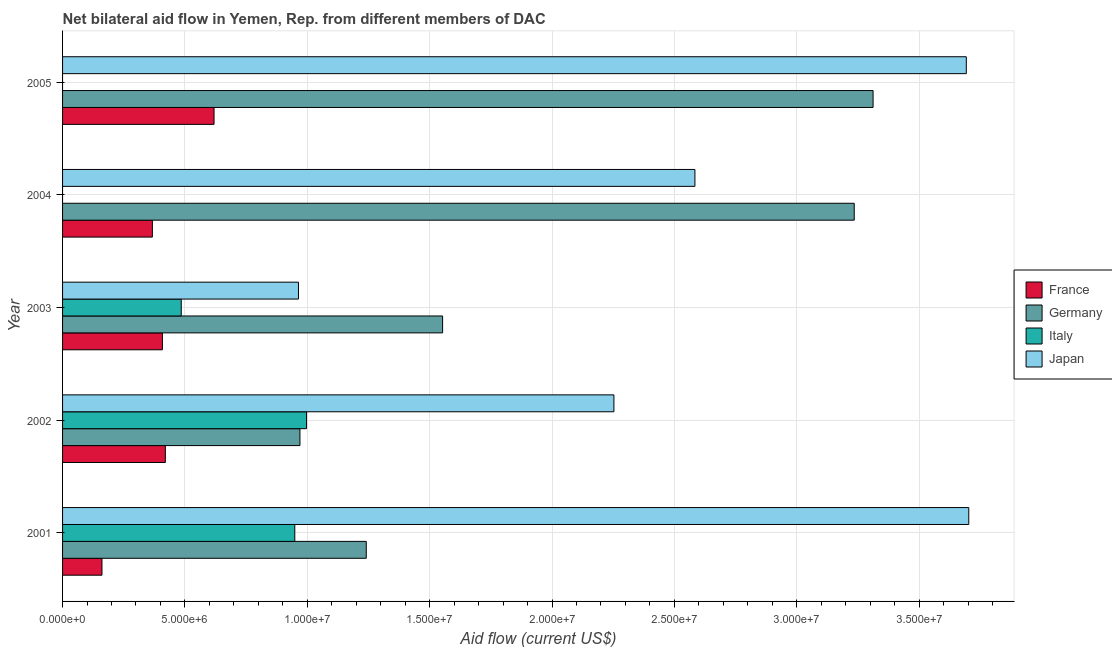How many different coloured bars are there?
Offer a very short reply. 4. How many bars are there on the 1st tick from the top?
Your answer should be compact. 3. How many bars are there on the 4th tick from the bottom?
Make the answer very short. 3. What is the label of the 5th group of bars from the top?
Offer a very short reply. 2001. In how many cases, is the number of bars for a given year not equal to the number of legend labels?
Make the answer very short. 2. What is the amount of aid given by france in 2001?
Provide a short and direct response. 1.61e+06. Across all years, what is the maximum amount of aid given by germany?
Your response must be concise. 3.31e+07. Across all years, what is the minimum amount of aid given by japan?
Offer a very short reply. 9.64e+06. In which year was the amount of aid given by italy maximum?
Your answer should be very brief. 2002. What is the total amount of aid given by germany in the graph?
Your response must be concise. 1.03e+08. What is the difference between the amount of aid given by france in 2003 and that in 2004?
Your answer should be very brief. 4.10e+05. What is the difference between the amount of aid given by japan in 2003 and the amount of aid given by italy in 2001?
Your answer should be very brief. 1.50e+05. What is the average amount of aid given by germany per year?
Your answer should be very brief. 2.06e+07. In the year 2003, what is the difference between the amount of aid given by japan and amount of aid given by france?
Offer a terse response. 5.56e+06. What is the ratio of the amount of aid given by japan in 2001 to that in 2005?
Give a very brief answer. 1. Is the amount of aid given by france in 2001 less than that in 2005?
Your answer should be compact. Yes. What is the difference between the highest and the second highest amount of aid given by italy?
Your answer should be compact. 4.80e+05. What is the difference between the highest and the lowest amount of aid given by france?
Make the answer very short. 4.58e+06. Is the sum of the amount of aid given by germany in 2003 and 2004 greater than the maximum amount of aid given by japan across all years?
Provide a succinct answer. Yes. Is it the case that in every year, the sum of the amount of aid given by italy and amount of aid given by germany is greater than the sum of amount of aid given by japan and amount of aid given by france?
Provide a succinct answer. No. Is it the case that in every year, the sum of the amount of aid given by france and amount of aid given by germany is greater than the amount of aid given by italy?
Keep it short and to the point. Yes. Are all the bars in the graph horizontal?
Offer a terse response. Yes. Where does the legend appear in the graph?
Ensure brevity in your answer.  Center right. What is the title of the graph?
Your answer should be very brief. Net bilateral aid flow in Yemen, Rep. from different members of DAC. What is the Aid flow (current US$) of France in 2001?
Keep it short and to the point. 1.61e+06. What is the Aid flow (current US$) of Germany in 2001?
Keep it short and to the point. 1.24e+07. What is the Aid flow (current US$) in Italy in 2001?
Provide a succinct answer. 9.49e+06. What is the Aid flow (current US$) of Japan in 2001?
Give a very brief answer. 3.70e+07. What is the Aid flow (current US$) in France in 2002?
Your response must be concise. 4.20e+06. What is the Aid flow (current US$) of Germany in 2002?
Give a very brief answer. 9.70e+06. What is the Aid flow (current US$) of Italy in 2002?
Keep it short and to the point. 9.97e+06. What is the Aid flow (current US$) in Japan in 2002?
Offer a terse response. 2.25e+07. What is the Aid flow (current US$) in France in 2003?
Your answer should be compact. 4.08e+06. What is the Aid flow (current US$) in Germany in 2003?
Give a very brief answer. 1.55e+07. What is the Aid flow (current US$) of Italy in 2003?
Your response must be concise. 4.85e+06. What is the Aid flow (current US$) in Japan in 2003?
Your answer should be compact. 9.64e+06. What is the Aid flow (current US$) in France in 2004?
Your answer should be very brief. 3.67e+06. What is the Aid flow (current US$) in Germany in 2004?
Your answer should be compact. 3.24e+07. What is the Aid flow (current US$) of Italy in 2004?
Provide a succinct answer. 0. What is the Aid flow (current US$) in Japan in 2004?
Your response must be concise. 2.58e+07. What is the Aid flow (current US$) of France in 2005?
Ensure brevity in your answer.  6.19e+06. What is the Aid flow (current US$) of Germany in 2005?
Your answer should be very brief. 3.31e+07. What is the Aid flow (current US$) in Italy in 2005?
Offer a very short reply. 0. What is the Aid flow (current US$) in Japan in 2005?
Your answer should be very brief. 3.69e+07. Across all years, what is the maximum Aid flow (current US$) of France?
Offer a very short reply. 6.19e+06. Across all years, what is the maximum Aid flow (current US$) in Germany?
Offer a terse response. 3.31e+07. Across all years, what is the maximum Aid flow (current US$) in Italy?
Provide a short and direct response. 9.97e+06. Across all years, what is the maximum Aid flow (current US$) of Japan?
Offer a terse response. 3.70e+07. Across all years, what is the minimum Aid flow (current US$) in France?
Give a very brief answer. 1.61e+06. Across all years, what is the minimum Aid flow (current US$) in Germany?
Your answer should be very brief. 9.70e+06. Across all years, what is the minimum Aid flow (current US$) of Italy?
Your answer should be compact. 0. Across all years, what is the minimum Aid flow (current US$) of Japan?
Provide a succinct answer. 9.64e+06. What is the total Aid flow (current US$) of France in the graph?
Your answer should be compact. 1.98e+07. What is the total Aid flow (current US$) of Germany in the graph?
Offer a terse response. 1.03e+08. What is the total Aid flow (current US$) in Italy in the graph?
Offer a terse response. 2.43e+07. What is the total Aid flow (current US$) of Japan in the graph?
Ensure brevity in your answer.  1.32e+08. What is the difference between the Aid flow (current US$) of France in 2001 and that in 2002?
Your answer should be very brief. -2.59e+06. What is the difference between the Aid flow (current US$) of Germany in 2001 and that in 2002?
Your response must be concise. 2.71e+06. What is the difference between the Aid flow (current US$) of Italy in 2001 and that in 2002?
Give a very brief answer. -4.80e+05. What is the difference between the Aid flow (current US$) in Japan in 2001 and that in 2002?
Your answer should be very brief. 1.45e+07. What is the difference between the Aid flow (current US$) in France in 2001 and that in 2003?
Your answer should be very brief. -2.47e+06. What is the difference between the Aid flow (current US$) in Germany in 2001 and that in 2003?
Make the answer very short. -3.12e+06. What is the difference between the Aid flow (current US$) of Italy in 2001 and that in 2003?
Give a very brief answer. 4.64e+06. What is the difference between the Aid flow (current US$) in Japan in 2001 and that in 2003?
Your answer should be compact. 2.74e+07. What is the difference between the Aid flow (current US$) in France in 2001 and that in 2004?
Provide a short and direct response. -2.06e+06. What is the difference between the Aid flow (current US$) of Germany in 2001 and that in 2004?
Ensure brevity in your answer.  -1.99e+07. What is the difference between the Aid flow (current US$) of Japan in 2001 and that in 2004?
Provide a short and direct response. 1.12e+07. What is the difference between the Aid flow (current US$) of France in 2001 and that in 2005?
Make the answer very short. -4.58e+06. What is the difference between the Aid flow (current US$) of Germany in 2001 and that in 2005?
Provide a succinct answer. -2.07e+07. What is the difference between the Aid flow (current US$) in Japan in 2001 and that in 2005?
Keep it short and to the point. 1.00e+05. What is the difference between the Aid flow (current US$) of Germany in 2002 and that in 2003?
Provide a short and direct response. -5.83e+06. What is the difference between the Aid flow (current US$) in Italy in 2002 and that in 2003?
Your answer should be compact. 5.12e+06. What is the difference between the Aid flow (current US$) of Japan in 2002 and that in 2003?
Your response must be concise. 1.29e+07. What is the difference between the Aid flow (current US$) of France in 2002 and that in 2004?
Keep it short and to the point. 5.30e+05. What is the difference between the Aid flow (current US$) in Germany in 2002 and that in 2004?
Your answer should be compact. -2.26e+07. What is the difference between the Aid flow (current US$) in Japan in 2002 and that in 2004?
Offer a terse response. -3.31e+06. What is the difference between the Aid flow (current US$) of France in 2002 and that in 2005?
Make the answer very short. -1.99e+06. What is the difference between the Aid flow (current US$) in Germany in 2002 and that in 2005?
Keep it short and to the point. -2.34e+07. What is the difference between the Aid flow (current US$) in Japan in 2002 and that in 2005?
Your answer should be very brief. -1.44e+07. What is the difference between the Aid flow (current US$) in France in 2003 and that in 2004?
Make the answer very short. 4.10e+05. What is the difference between the Aid flow (current US$) in Germany in 2003 and that in 2004?
Keep it short and to the point. -1.68e+07. What is the difference between the Aid flow (current US$) in Japan in 2003 and that in 2004?
Keep it short and to the point. -1.62e+07. What is the difference between the Aid flow (current US$) in France in 2003 and that in 2005?
Ensure brevity in your answer.  -2.11e+06. What is the difference between the Aid flow (current US$) of Germany in 2003 and that in 2005?
Your response must be concise. -1.76e+07. What is the difference between the Aid flow (current US$) in Japan in 2003 and that in 2005?
Keep it short and to the point. -2.73e+07. What is the difference between the Aid flow (current US$) of France in 2004 and that in 2005?
Provide a succinct answer. -2.52e+06. What is the difference between the Aid flow (current US$) of Germany in 2004 and that in 2005?
Your answer should be very brief. -7.70e+05. What is the difference between the Aid flow (current US$) in Japan in 2004 and that in 2005?
Your answer should be very brief. -1.11e+07. What is the difference between the Aid flow (current US$) of France in 2001 and the Aid flow (current US$) of Germany in 2002?
Keep it short and to the point. -8.09e+06. What is the difference between the Aid flow (current US$) of France in 2001 and the Aid flow (current US$) of Italy in 2002?
Offer a very short reply. -8.36e+06. What is the difference between the Aid flow (current US$) of France in 2001 and the Aid flow (current US$) of Japan in 2002?
Keep it short and to the point. -2.09e+07. What is the difference between the Aid flow (current US$) in Germany in 2001 and the Aid flow (current US$) in Italy in 2002?
Make the answer very short. 2.44e+06. What is the difference between the Aid flow (current US$) in Germany in 2001 and the Aid flow (current US$) in Japan in 2002?
Offer a terse response. -1.01e+07. What is the difference between the Aid flow (current US$) in Italy in 2001 and the Aid flow (current US$) in Japan in 2002?
Provide a succinct answer. -1.30e+07. What is the difference between the Aid flow (current US$) of France in 2001 and the Aid flow (current US$) of Germany in 2003?
Your answer should be compact. -1.39e+07. What is the difference between the Aid flow (current US$) of France in 2001 and the Aid flow (current US$) of Italy in 2003?
Make the answer very short. -3.24e+06. What is the difference between the Aid flow (current US$) of France in 2001 and the Aid flow (current US$) of Japan in 2003?
Offer a terse response. -8.03e+06. What is the difference between the Aid flow (current US$) of Germany in 2001 and the Aid flow (current US$) of Italy in 2003?
Your response must be concise. 7.56e+06. What is the difference between the Aid flow (current US$) in Germany in 2001 and the Aid flow (current US$) in Japan in 2003?
Your answer should be compact. 2.77e+06. What is the difference between the Aid flow (current US$) of France in 2001 and the Aid flow (current US$) of Germany in 2004?
Make the answer very short. -3.07e+07. What is the difference between the Aid flow (current US$) in France in 2001 and the Aid flow (current US$) in Japan in 2004?
Ensure brevity in your answer.  -2.42e+07. What is the difference between the Aid flow (current US$) in Germany in 2001 and the Aid flow (current US$) in Japan in 2004?
Your answer should be compact. -1.34e+07. What is the difference between the Aid flow (current US$) of Italy in 2001 and the Aid flow (current US$) of Japan in 2004?
Provide a short and direct response. -1.64e+07. What is the difference between the Aid flow (current US$) of France in 2001 and the Aid flow (current US$) of Germany in 2005?
Provide a succinct answer. -3.15e+07. What is the difference between the Aid flow (current US$) in France in 2001 and the Aid flow (current US$) in Japan in 2005?
Offer a terse response. -3.53e+07. What is the difference between the Aid flow (current US$) in Germany in 2001 and the Aid flow (current US$) in Japan in 2005?
Your answer should be very brief. -2.45e+07. What is the difference between the Aid flow (current US$) in Italy in 2001 and the Aid flow (current US$) in Japan in 2005?
Your answer should be very brief. -2.74e+07. What is the difference between the Aid flow (current US$) of France in 2002 and the Aid flow (current US$) of Germany in 2003?
Your response must be concise. -1.13e+07. What is the difference between the Aid flow (current US$) in France in 2002 and the Aid flow (current US$) in Italy in 2003?
Give a very brief answer. -6.50e+05. What is the difference between the Aid flow (current US$) in France in 2002 and the Aid flow (current US$) in Japan in 2003?
Offer a very short reply. -5.44e+06. What is the difference between the Aid flow (current US$) in Germany in 2002 and the Aid flow (current US$) in Italy in 2003?
Offer a terse response. 4.85e+06. What is the difference between the Aid flow (current US$) of Germany in 2002 and the Aid flow (current US$) of Japan in 2003?
Ensure brevity in your answer.  6.00e+04. What is the difference between the Aid flow (current US$) of Italy in 2002 and the Aid flow (current US$) of Japan in 2003?
Your answer should be very brief. 3.30e+05. What is the difference between the Aid flow (current US$) in France in 2002 and the Aid flow (current US$) in Germany in 2004?
Your answer should be very brief. -2.82e+07. What is the difference between the Aid flow (current US$) of France in 2002 and the Aid flow (current US$) of Japan in 2004?
Your answer should be very brief. -2.16e+07. What is the difference between the Aid flow (current US$) in Germany in 2002 and the Aid flow (current US$) in Japan in 2004?
Make the answer very short. -1.61e+07. What is the difference between the Aid flow (current US$) in Italy in 2002 and the Aid flow (current US$) in Japan in 2004?
Provide a succinct answer. -1.59e+07. What is the difference between the Aid flow (current US$) in France in 2002 and the Aid flow (current US$) in Germany in 2005?
Your answer should be compact. -2.89e+07. What is the difference between the Aid flow (current US$) of France in 2002 and the Aid flow (current US$) of Japan in 2005?
Provide a short and direct response. -3.27e+07. What is the difference between the Aid flow (current US$) of Germany in 2002 and the Aid flow (current US$) of Japan in 2005?
Keep it short and to the point. -2.72e+07. What is the difference between the Aid flow (current US$) in Italy in 2002 and the Aid flow (current US$) in Japan in 2005?
Make the answer very short. -2.70e+07. What is the difference between the Aid flow (current US$) of France in 2003 and the Aid flow (current US$) of Germany in 2004?
Your response must be concise. -2.83e+07. What is the difference between the Aid flow (current US$) in France in 2003 and the Aid flow (current US$) in Japan in 2004?
Your response must be concise. -2.18e+07. What is the difference between the Aid flow (current US$) of Germany in 2003 and the Aid flow (current US$) of Japan in 2004?
Your response must be concise. -1.03e+07. What is the difference between the Aid flow (current US$) of Italy in 2003 and the Aid flow (current US$) of Japan in 2004?
Your answer should be compact. -2.10e+07. What is the difference between the Aid flow (current US$) of France in 2003 and the Aid flow (current US$) of Germany in 2005?
Keep it short and to the point. -2.90e+07. What is the difference between the Aid flow (current US$) of France in 2003 and the Aid flow (current US$) of Japan in 2005?
Keep it short and to the point. -3.28e+07. What is the difference between the Aid flow (current US$) in Germany in 2003 and the Aid flow (current US$) in Japan in 2005?
Make the answer very short. -2.14e+07. What is the difference between the Aid flow (current US$) of Italy in 2003 and the Aid flow (current US$) of Japan in 2005?
Ensure brevity in your answer.  -3.21e+07. What is the difference between the Aid flow (current US$) of France in 2004 and the Aid flow (current US$) of Germany in 2005?
Offer a terse response. -2.94e+07. What is the difference between the Aid flow (current US$) of France in 2004 and the Aid flow (current US$) of Japan in 2005?
Keep it short and to the point. -3.33e+07. What is the difference between the Aid flow (current US$) in Germany in 2004 and the Aid flow (current US$) in Japan in 2005?
Your answer should be compact. -4.58e+06. What is the average Aid flow (current US$) in France per year?
Make the answer very short. 3.95e+06. What is the average Aid flow (current US$) in Germany per year?
Your answer should be compact. 2.06e+07. What is the average Aid flow (current US$) in Italy per year?
Offer a terse response. 4.86e+06. What is the average Aid flow (current US$) in Japan per year?
Offer a terse response. 2.64e+07. In the year 2001, what is the difference between the Aid flow (current US$) in France and Aid flow (current US$) in Germany?
Offer a very short reply. -1.08e+07. In the year 2001, what is the difference between the Aid flow (current US$) of France and Aid flow (current US$) of Italy?
Offer a very short reply. -7.88e+06. In the year 2001, what is the difference between the Aid flow (current US$) in France and Aid flow (current US$) in Japan?
Provide a short and direct response. -3.54e+07. In the year 2001, what is the difference between the Aid flow (current US$) in Germany and Aid flow (current US$) in Italy?
Offer a terse response. 2.92e+06. In the year 2001, what is the difference between the Aid flow (current US$) of Germany and Aid flow (current US$) of Japan?
Your answer should be compact. -2.46e+07. In the year 2001, what is the difference between the Aid flow (current US$) in Italy and Aid flow (current US$) in Japan?
Offer a terse response. -2.75e+07. In the year 2002, what is the difference between the Aid flow (current US$) of France and Aid flow (current US$) of Germany?
Ensure brevity in your answer.  -5.50e+06. In the year 2002, what is the difference between the Aid flow (current US$) of France and Aid flow (current US$) of Italy?
Your answer should be very brief. -5.77e+06. In the year 2002, what is the difference between the Aid flow (current US$) in France and Aid flow (current US$) in Japan?
Ensure brevity in your answer.  -1.83e+07. In the year 2002, what is the difference between the Aid flow (current US$) of Germany and Aid flow (current US$) of Italy?
Ensure brevity in your answer.  -2.70e+05. In the year 2002, what is the difference between the Aid flow (current US$) of Germany and Aid flow (current US$) of Japan?
Keep it short and to the point. -1.28e+07. In the year 2002, what is the difference between the Aid flow (current US$) in Italy and Aid flow (current US$) in Japan?
Ensure brevity in your answer.  -1.26e+07. In the year 2003, what is the difference between the Aid flow (current US$) in France and Aid flow (current US$) in Germany?
Provide a short and direct response. -1.14e+07. In the year 2003, what is the difference between the Aid flow (current US$) in France and Aid flow (current US$) in Italy?
Ensure brevity in your answer.  -7.70e+05. In the year 2003, what is the difference between the Aid flow (current US$) in France and Aid flow (current US$) in Japan?
Give a very brief answer. -5.56e+06. In the year 2003, what is the difference between the Aid flow (current US$) in Germany and Aid flow (current US$) in Italy?
Ensure brevity in your answer.  1.07e+07. In the year 2003, what is the difference between the Aid flow (current US$) of Germany and Aid flow (current US$) of Japan?
Ensure brevity in your answer.  5.89e+06. In the year 2003, what is the difference between the Aid flow (current US$) of Italy and Aid flow (current US$) of Japan?
Provide a succinct answer. -4.79e+06. In the year 2004, what is the difference between the Aid flow (current US$) of France and Aid flow (current US$) of Germany?
Make the answer very short. -2.87e+07. In the year 2004, what is the difference between the Aid flow (current US$) in France and Aid flow (current US$) in Japan?
Make the answer very short. -2.22e+07. In the year 2004, what is the difference between the Aid flow (current US$) in Germany and Aid flow (current US$) in Japan?
Give a very brief answer. 6.51e+06. In the year 2005, what is the difference between the Aid flow (current US$) of France and Aid flow (current US$) of Germany?
Provide a short and direct response. -2.69e+07. In the year 2005, what is the difference between the Aid flow (current US$) of France and Aid flow (current US$) of Japan?
Provide a succinct answer. -3.07e+07. In the year 2005, what is the difference between the Aid flow (current US$) of Germany and Aid flow (current US$) of Japan?
Make the answer very short. -3.81e+06. What is the ratio of the Aid flow (current US$) in France in 2001 to that in 2002?
Ensure brevity in your answer.  0.38. What is the ratio of the Aid flow (current US$) of Germany in 2001 to that in 2002?
Offer a terse response. 1.28. What is the ratio of the Aid flow (current US$) of Italy in 2001 to that in 2002?
Your answer should be compact. 0.95. What is the ratio of the Aid flow (current US$) in Japan in 2001 to that in 2002?
Your response must be concise. 1.64. What is the ratio of the Aid flow (current US$) in France in 2001 to that in 2003?
Provide a succinct answer. 0.39. What is the ratio of the Aid flow (current US$) in Germany in 2001 to that in 2003?
Keep it short and to the point. 0.8. What is the ratio of the Aid flow (current US$) in Italy in 2001 to that in 2003?
Make the answer very short. 1.96. What is the ratio of the Aid flow (current US$) of Japan in 2001 to that in 2003?
Provide a short and direct response. 3.84. What is the ratio of the Aid flow (current US$) in France in 2001 to that in 2004?
Make the answer very short. 0.44. What is the ratio of the Aid flow (current US$) of Germany in 2001 to that in 2004?
Offer a very short reply. 0.38. What is the ratio of the Aid flow (current US$) in Japan in 2001 to that in 2004?
Keep it short and to the point. 1.43. What is the ratio of the Aid flow (current US$) of France in 2001 to that in 2005?
Your answer should be very brief. 0.26. What is the ratio of the Aid flow (current US$) in Germany in 2001 to that in 2005?
Provide a succinct answer. 0.37. What is the ratio of the Aid flow (current US$) of France in 2002 to that in 2003?
Your answer should be very brief. 1.03. What is the ratio of the Aid flow (current US$) of Germany in 2002 to that in 2003?
Make the answer very short. 0.62. What is the ratio of the Aid flow (current US$) in Italy in 2002 to that in 2003?
Your answer should be compact. 2.06. What is the ratio of the Aid flow (current US$) of Japan in 2002 to that in 2003?
Ensure brevity in your answer.  2.34. What is the ratio of the Aid flow (current US$) of France in 2002 to that in 2004?
Your response must be concise. 1.14. What is the ratio of the Aid flow (current US$) of Germany in 2002 to that in 2004?
Provide a short and direct response. 0.3. What is the ratio of the Aid flow (current US$) in Japan in 2002 to that in 2004?
Give a very brief answer. 0.87. What is the ratio of the Aid flow (current US$) in France in 2002 to that in 2005?
Keep it short and to the point. 0.68. What is the ratio of the Aid flow (current US$) in Germany in 2002 to that in 2005?
Keep it short and to the point. 0.29. What is the ratio of the Aid flow (current US$) of Japan in 2002 to that in 2005?
Your response must be concise. 0.61. What is the ratio of the Aid flow (current US$) in France in 2003 to that in 2004?
Ensure brevity in your answer.  1.11. What is the ratio of the Aid flow (current US$) in Germany in 2003 to that in 2004?
Your response must be concise. 0.48. What is the ratio of the Aid flow (current US$) in Japan in 2003 to that in 2004?
Keep it short and to the point. 0.37. What is the ratio of the Aid flow (current US$) of France in 2003 to that in 2005?
Provide a short and direct response. 0.66. What is the ratio of the Aid flow (current US$) in Germany in 2003 to that in 2005?
Your response must be concise. 0.47. What is the ratio of the Aid flow (current US$) in Japan in 2003 to that in 2005?
Offer a very short reply. 0.26. What is the ratio of the Aid flow (current US$) of France in 2004 to that in 2005?
Your answer should be compact. 0.59. What is the ratio of the Aid flow (current US$) in Germany in 2004 to that in 2005?
Your answer should be compact. 0.98. What is the ratio of the Aid flow (current US$) of Japan in 2004 to that in 2005?
Provide a succinct answer. 0.7. What is the difference between the highest and the second highest Aid flow (current US$) in France?
Your answer should be compact. 1.99e+06. What is the difference between the highest and the second highest Aid flow (current US$) of Germany?
Your answer should be very brief. 7.70e+05. What is the difference between the highest and the second highest Aid flow (current US$) of Italy?
Keep it short and to the point. 4.80e+05. What is the difference between the highest and the lowest Aid flow (current US$) of France?
Offer a terse response. 4.58e+06. What is the difference between the highest and the lowest Aid flow (current US$) of Germany?
Provide a succinct answer. 2.34e+07. What is the difference between the highest and the lowest Aid flow (current US$) of Italy?
Offer a very short reply. 9.97e+06. What is the difference between the highest and the lowest Aid flow (current US$) in Japan?
Your answer should be compact. 2.74e+07. 